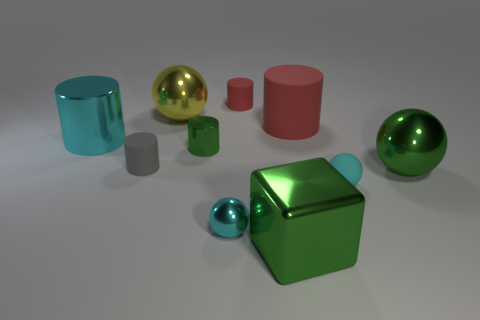What size is the green shiny thing that is both left of the big matte cylinder and in front of the gray thing? The green shiny object to the left of the large matte cylinder and in front of the gray object appears to be medium-sized in comparison to the other objects in the image. 